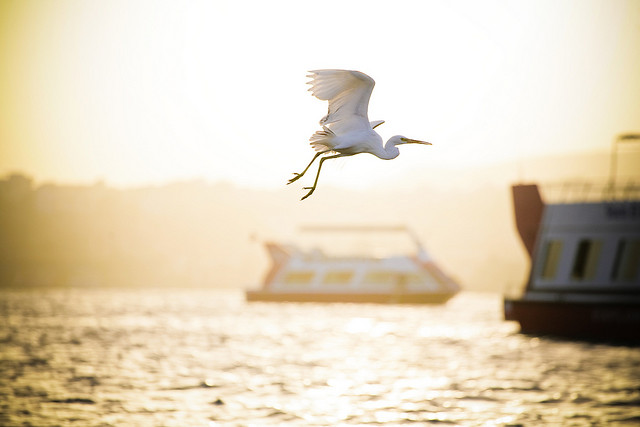Please provide the bounding box coordinate of the region this sentence describes: a white boat to the right of a bird. The bounding box coordinates for 'a white boat to the right of a bird' are [0.78, 0.37, 1.0, 0.72]. 